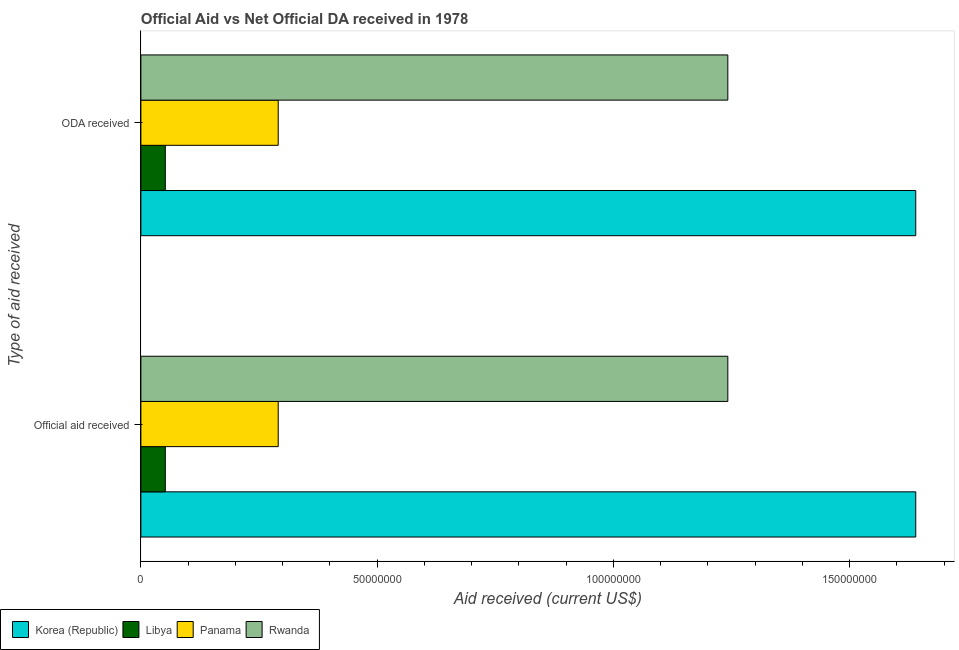How many different coloured bars are there?
Your answer should be compact. 4. Are the number of bars per tick equal to the number of legend labels?
Your answer should be compact. Yes. How many bars are there on the 2nd tick from the top?
Your answer should be very brief. 4. How many bars are there on the 1st tick from the bottom?
Ensure brevity in your answer.  4. What is the label of the 2nd group of bars from the top?
Your answer should be very brief. Official aid received. What is the oda received in Panama?
Your response must be concise. 2.91e+07. Across all countries, what is the maximum oda received?
Keep it short and to the point. 1.64e+08. Across all countries, what is the minimum oda received?
Make the answer very short. 5.17e+06. In which country was the oda received minimum?
Your response must be concise. Libya. What is the total oda received in the graph?
Provide a succinct answer. 3.22e+08. What is the difference between the oda received in Libya and that in Rwanda?
Offer a very short reply. -1.19e+08. What is the difference between the oda received in Rwanda and the official aid received in Libya?
Ensure brevity in your answer.  1.19e+08. What is the average oda received per country?
Keep it short and to the point. 8.06e+07. In how many countries, is the official aid received greater than 120000000 US$?
Make the answer very short. 2. What is the ratio of the oda received in Libya to that in Panama?
Offer a terse response. 0.18. What does the 3rd bar from the bottom in ODA received represents?
Ensure brevity in your answer.  Panama. How many countries are there in the graph?
Give a very brief answer. 4. What is the difference between two consecutive major ticks on the X-axis?
Provide a succinct answer. 5.00e+07. Are the values on the major ticks of X-axis written in scientific E-notation?
Offer a terse response. No. Does the graph contain any zero values?
Your answer should be very brief. No. Does the graph contain grids?
Ensure brevity in your answer.  No. How are the legend labels stacked?
Provide a short and direct response. Horizontal. What is the title of the graph?
Ensure brevity in your answer.  Official Aid vs Net Official DA received in 1978 . Does "Maldives" appear as one of the legend labels in the graph?
Provide a short and direct response. No. What is the label or title of the X-axis?
Offer a terse response. Aid received (current US$). What is the label or title of the Y-axis?
Ensure brevity in your answer.  Type of aid received. What is the Aid received (current US$) in Korea (Republic) in Official aid received?
Your answer should be very brief. 1.64e+08. What is the Aid received (current US$) of Libya in Official aid received?
Your answer should be very brief. 5.17e+06. What is the Aid received (current US$) in Panama in Official aid received?
Give a very brief answer. 2.91e+07. What is the Aid received (current US$) in Rwanda in Official aid received?
Offer a terse response. 1.24e+08. What is the Aid received (current US$) in Korea (Republic) in ODA received?
Ensure brevity in your answer.  1.64e+08. What is the Aid received (current US$) of Libya in ODA received?
Offer a terse response. 5.17e+06. What is the Aid received (current US$) of Panama in ODA received?
Keep it short and to the point. 2.91e+07. What is the Aid received (current US$) in Rwanda in ODA received?
Provide a succinct answer. 1.24e+08. Across all Type of aid received, what is the maximum Aid received (current US$) of Korea (Republic)?
Ensure brevity in your answer.  1.64e+08. Across all Type of aid received, what is the maximum Aid received (current US$) in Libya?
Keep it short and to the point. 5.17e+06. Across all Type of aid received, what is the maximum Aid received (current US$) in Panama?
Offer a very short reply. 2.91e+07. Across all Type of aid received, what is the maximum Aid received (current US$) of Rwanda?
Provide a succinct answer. 1.24e+08. Across all Type of aid received, what is the minimum Aid received (current US$) of Korea (Republic)?
Your answer should be compact. 1.64e+08. Across all Type of aid received, what is the minimum Aid received (current US$) of Libya?
Your answer should be very brief. 5.17e+06. Across all Type of aid received, what is the minimum Aid received (current US$) of Panama?
Ensure brevity in your answer.  2.91e+07. Across all Type of aid received, what is the minimum Aid received (current US$) of Rwanda?
Offer a terse response. 1.24e+08. What is the total Aid received (current US$) of Korea (Republic) in the graph?
Make the answer very short. 3.28e+08. What is the total Aid received (current US$) of Libya in the graph?
Your answer should be very brief. 1.03e+07. What is the total Aid received (current US$) of Panama in the graph?
Your answer should be very brief. 5.81e+07. What is the total Aid received (current US$) in Rwanda in the graph?
Provide a succinct answer. 2.48e+08. What is the difference between the Aid received (current US$) in Libya in Official aid received and that in ODA received?
Give a very brief answer. 0. What is the difference between the Aid received (current US$) in Rwanda in Official aid received and that in ODA received?
Keep it short and to the point. 0. What is the difference between the Aid received (current US$) of Korea (Republic) in Official aid received and the Aid received (current US$) of Libya in ODA received?
Keep it short and to the point. 1.59e+08. What is the difference between the Aid received (current US$) of Korea (Republic) in Official aid received and the Aid received (current US$) of Panama in ODA received?
Your answer should be compact. 1.35e+08. What is the difference between the Aid received (current US$) of Korea (Republic) in Official aid received and the Aid received (current US$) of Rwanda in ODA received?
Make the answer very short. 3.98e+07. What is the difference between the Aid received (current US$) of Libya in Official aid received and the Aid received (current US$) of Panama in ODA received?
Make the answer very short. -2.39e+07. What is the difference between the Aid received (current US$) in Libya in Official aid received and the Aid received (current US$) in Rwanda in ODA received?
Keep it short and to the point. -1.19e+08. What is the difference between the Aid received (current US$) of Panama in Official aid received and the Aid received (current US$) of Rwanda in ODA received?
Offer a very short reply. -9.52e+07. What is the average Aid received (current US$) in Korea (Republic) per Type of aid received?
Your response must be concise. 1.64e+08. What is the average Aid received (current US$) in Libya per Type of aid received?
Your response must be concise. 5.17e+06. What is the average Aid received (current US$) in Panama per Type of aid received?
Keep it short and to the point. 2.91e+07. What is the average Aid received (current US$) of Rwanda per Type of aid received?
Your response must be concise. 1.24e+08. What is the difference between the Aid received (current US$) in Korea (Republic) and Aid received (current US$) in Libya in Official aid received?
Provide a short and direct response. 1.59e+08. What is the difference between the Aid received (current US$) of Korea (Republic) and Aid received (current US$) of Panama in Official aid received?
Offer a terse response. 1.35e+08. What is the difference between the Aid received (current US$) of Korea (Republic) and Aid received (current US$) of Rwanda in Official aid received?
Ensure brevity in your answer.  3.98e+07. What is the difference between the Aid received (current US$) in Libya and Aid received (current US$) in Panama in Official aid received?
Your answer should be compact. -2.39e+07. What is the difference between the Aid received (current US$) of Libya and Aid received (current US$) of Rwanda in Official aid received?
Your answer should be compact. -1.19e+08. What is the difference between the Aid received (current US$) in Panama and Aid received (current US$) in Rwanda in Official aid received?
Ensure brevity in your answer.  -9.52e+07. What is the difference between the Aid received (current US$) in Korea (Republic) and Aid received (current US$) in Libya in ODA received?
Your answer should be compact. 1.59e+08. What is the difference between the Aid received (current US$) of Korea (Republic) and Aid received (current US$) of Panama in ODA received?
Make the answer very short. 1.35e+08. What is the difference between the Aid received (current US$) in Korea (Republic) and Aid received (current US$) in Rwanda in ODA received?
Give a very brief answer. 3.98e+07. What is the difference between the Aid received (current US$) of Libya and Aid received (current US$) of Panama in ODA received?
Provide a succinct answer. -2.39e+07. What is the difference between the Aid received (current US$) in Libya and Aid received (current US$) in Rwanda in ODA received?
Your answer should be compact. -1.19e+08. What is the difference between the Aid received (current US$) in Panama and Aid received (current US$) in Rwanda in ODA received?
Ensure brevity in your answer.  -9.52e+07. What is the ratio of the Aid received (current US$) of Libya in Official aid received to that in ODA received?
Give a very brief answer. 1. What is the ratio of the Aid received (current US$) in Rwanda in Official aid received to that in ODA received?
Ensure brevity in your answer.  1. What is the difference between the highest and the second highest Aid received (current US$) of Panama?
Ensure brevity in your answer.  0. What is the difference between the highest and the lowest Aid received (current US$) in Panama?
Provide a short and direct response. 0. 